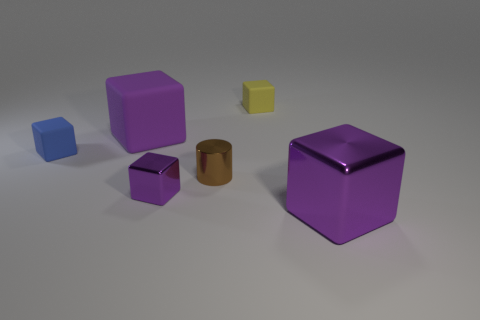Subtract all green cylinders. How many purple cubes are left? 3 Subtract all blue blocks. How many blocks are left? 4 Subtract all tiny metal blocks. How many blocks are left? 4 Subtract all red blocks. Subtract all purple cylinders. How many blocks are left? 5 Add 4 cyan objects. How many objects exist? 10 Subtract all cylinders. How many objects are left? 5 Add 4 small shiny cubes. How many small shiny cubes are left? 5 Add 1 red rubber cylinders. How many red rubber cylinders exist? 1 Subtract 1 brown cylinders. How many objects are left? 5 Subtract all large matte cubes. Subtract all brown objects. How many objects are left? 4 